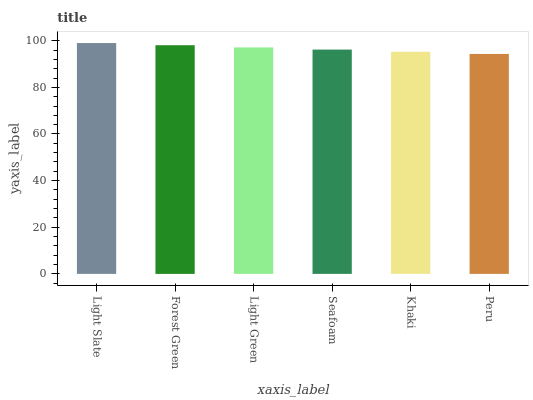Is Peru the minimum?
Answer yes or no. Yes. Is Light Slate the maximum?
Answer yes or no. Yes. Is Forest Green the minimum?
Answer yes or no. No. Is Forest Green the maximum?
Answer yes or no. No. Is Light Slate greater than Forest Green?
Answer yes or no. Yes. Is Forest Green less than Light Slate?
Answer yes or no. Yes. Is Forest Green greater than Light Slate?
Answer yes or no. No. Is Light Slate less than Forest Green?
Answer yes or no. No. Is Light Green the high median?
Answer yes or no. Yes. Is Seafoam the low median?
Answer yes or no. Yes. Is Light Slate the high median?
Answer yes or no. No. Is Light Slate the low median?
Answer yes or no. No. 